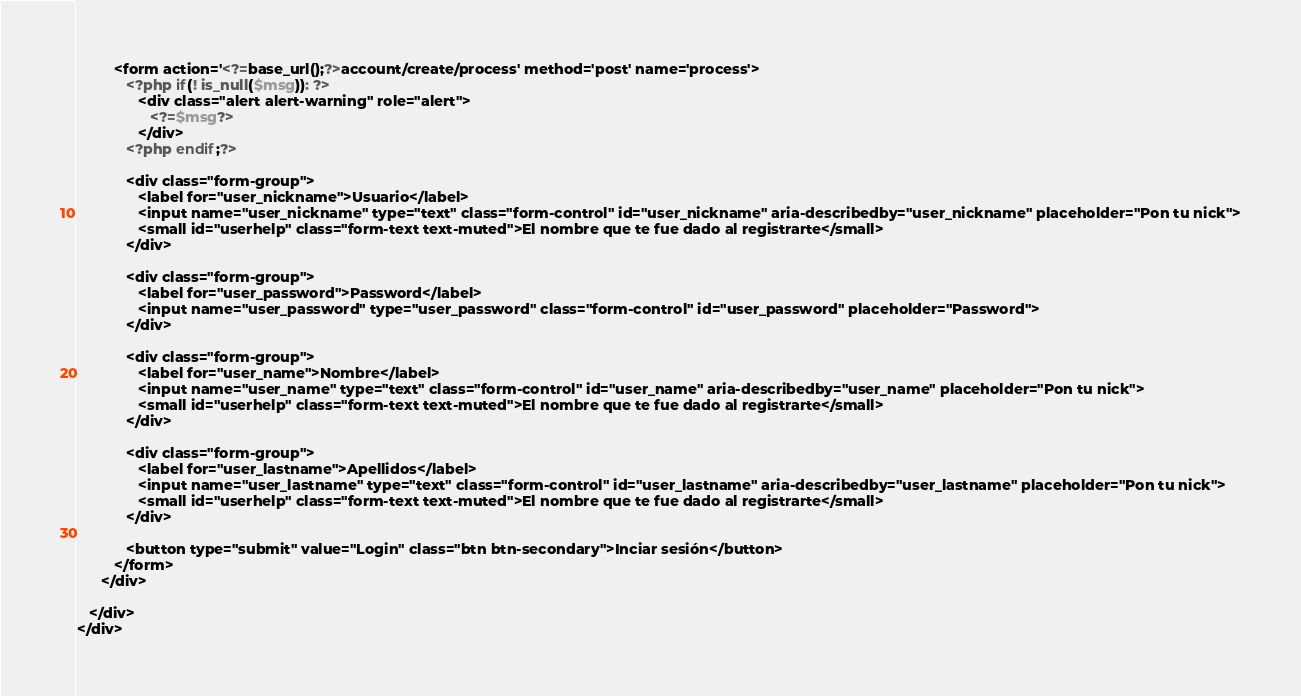Convert code to text. <code><loc_0><loc_0><loc_500><loc_500><_PHP_>         <form action='<?=base_url();?>account/create/process' method='post' name='process'>
            <?php if(! is_null($msg)): ?>
               <div class="alert alert-warning" role="alert">
                  <?=$msg?>
               </div>
            <?php endif;?>

            <div class="form-group">
               <label for="user_nickname">Usuario</label>
               <input name="user_nickname" type="text" class="form-control" id="user_nickname" aria-describedby="user_nickname" placeholder="Pon tu nick">
               <small id="userhelp" class="form-text text-muted">El nombre que te fue dado al registrarte</small>
            </div>

            <div class="form-group">
               <label for="user_password">Password</label>
               <input name="user_password" type="user_password" class="form-control" id="user_password" placeholder="Password">
            </div>

            <div class="form-group">
               <label for="user_name">Nombre</label>
               <input name="user_name" type="text" class="form-control" id="user_name" aria-describedby="user_name" placeholder="Pon tu nick">
               <small id="userhelp" class="form-text text-muted">El nombre que te fue dado al registrarte</small>
            </div>

            <div class="form-group">
               <label for="user_lastname">Apellidos</label>
               <input name="user_lastname" type="text" class="form-control" id="user_lastname" aria-describedby="user_lastname" placeholder="Pon tu nick">
               <small id="userhelp" class="form-text text-muted">El nombre que te fue dado al registrarte</small>
            </div>

            <button type="submit" value="Login" class="btn btn-secondary">Inciar sesión</button>
         </form>
      </div>
      
   </div>
</div></code> 